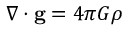Convert formula to latex. <formula><loc_0><loc_0><loc_500><loc_500>\nabla \cdot g = 4 \pi G \rho \,</formula> 